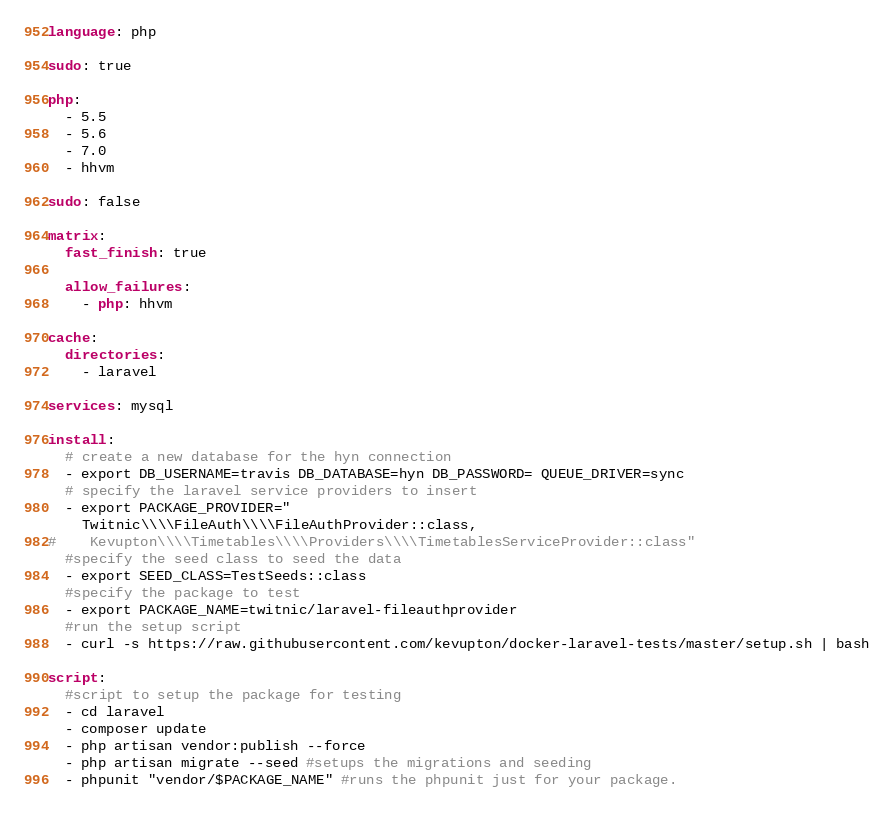<code> <loc_0><loc_0><loc_500><loc_500><_YAML_>language: php

sudo: true

php:
  - 5.5
  - 5.6
  - 7.0
  - hhvm

sudo: false

matrix:
  fast_finish: true

  allow_failures:
    - php: hhvm

cache:
  directories:
    - laravel

services: mysql

install:
  # create a new database for the hyn connection
  - export DB_USERNAME=travis DB_DATABASE=hyn DB_PASSWORD= QUEUE_DRIVER=sync
  # specify the laravel service providers to insert
  - export PACKAGE_PROVIDER="
    Twitnic\\\\FileAuth\\\\FileAuthProvider::class,
#    Kevupton\\\\Timetables\\\\Providers\\\\TimetablesServiceProvider::class"
  #specify the seed class to seed the data
  - export SEED_CLASS=TestSeeds::class
  #specify the package to test
  - export PACKAGE_NAME=twitnic/laravel-fileauthprovider
  #run the setup script
  - curl -s https://raw.githubusercontent.com/kevupton/docker-laravel-tests/master/setup.sh | bash

script:
  #script to setup the package for testing
  - cd laravel
  - composer update
  - php artisan vendor:publish --force
  - php artisan migrate --seed #setups the migrations and seeding
  - phpunit "vendor/$PACKAGE_NAME" #runs the phpunit just for your package.
</code> 